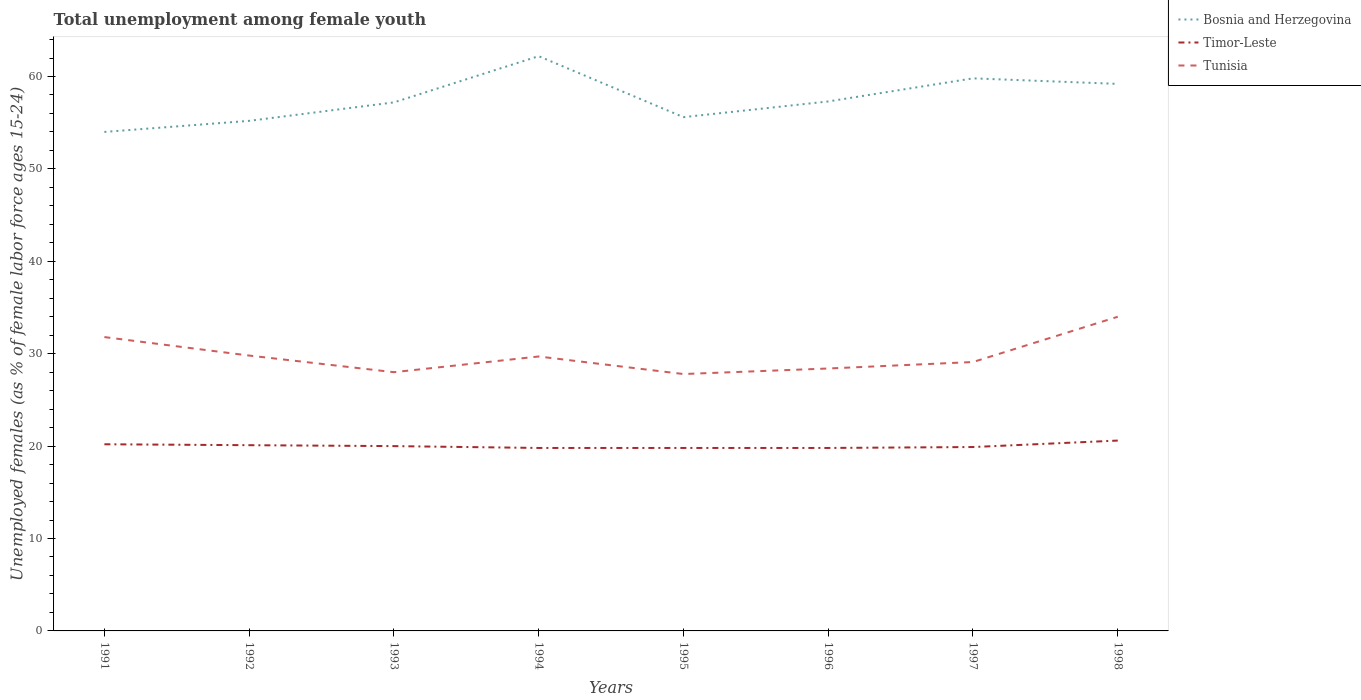Is the number of lines equal to the number of legend labels?
Give a very brief answer. Yes. Across all years, what is the maximum percentage of unemployed females in in Timor-Leste?
Make the answer very short. 19.8. What is the difference between the highest and the second highest percentage of unemployed females in in Timor-Leste?
Offer a very short reply. 0.8. What is the difference between the highest and the lowest percentage of unemployed females in in Bosnia and Herzegovina?
Make the answer very short. 3. Is the percentage of unemployed females in in Tunisia strictly greater than the percentage of unemployed females in in Bosnia and Herzegovina over the years?
Make the answer very short. Yes. How many years are there in the graph?
Provide a short and direct response. 8. What is the difference between two consecutive major ticks on the Y-axis?
Your answer should be very brief. 10. Are the values on the major ticks of Y-axis written in scientific E-notation?
Provide a succinct answer. No. Does the graph contain any zero values?
Offer a very short reply. No. Does the graph contain grids?
Ensure brevity in your answer.  No. Where does the legend appear in the graph?
Make the answer very short. Top right. How many legend labels are there?
Offer a very short reply. 3. How are the legend labels stacked?
Offer a very short reply. Vertical. What is the title of the graph?
Provide a short and direct response. Total unemployment among female youth. What is the label or title of the Y-axis?
Offer a terse response. Unemployed females (as % of female labor force ages 15-24). What is the Unemployed females (as % of female labor force ages 15-24) of Bosnia and Herzegovina in 1991?
Provide a short and direct response. 54. What is the Unemployed females (as % of female labor force ages 15-24) in Timor-Leste in 1991?
Provide a succinct answer. 20.2. What is the Unemployed females (as % of female labor force ages 15-24) of Tunisia in 1991?
Your answer should be very brief. 31.8. What is the Unemployed females (as % of female labor force ages 15-24) of Bosnia and Herzegovina in 1992?
Your answer should be compact. 55.2. What is the Unemployed females (as % of female labor force ages 15-24) of Timor-Leste in 1992?
Offer a terse response. 20.1. What is the Unemployed females (as % of female labor force ages 15-24) of Tunisia in 1992?
Make the answer very short. 29.8. What is the Unemployed females (as % of female labor force ages 15-24) in Bosnia and Herzegovina in 1993?
Offer a terse response. 57.2. What is the Unemployed females (as % of female labor force ages 15-24) in Tunisia in 1993?
Ensure brevity in your answer.  28. What is the Unemployed females (as % of female labor force ages 15-24) in Bosnia and Herzegovina in 1994?
Provide a short and direct response. 62.2. What is the Unemployed females (as % of female labor force ages 15-24) of Timor-Leste in 1994?
Keep it short and to the point. 19.8. What is the Unemployed females (as % of female labor force ages 15-24) of Tunisia in 1994?
Give a very brief answer. 29.7. What is the Unemployed females (as % of female labor force ages 15-24) of Bosnia and Herzegovina in 1995?
Your answer should be compact. 55.6. What is the Unemployed females (as % of female labor force ages 15-24) of Timor-Leste in 1995?
Provide a short and direct response. 19.8. What is the Unemployed females (as % of female labor force ages 15-24) of Tunisia in 1995?
Give a very brief answer. 27.8. What is the Unemployed females (as % of female labor force ages 15-24) of Bosnia and Herzegovina in 1996?
Make the answer very short. 57.3. What is the Unemployed females (as % of female labor force ages 15-24) of Timor-Leste in 1996?
Offer a terse response. 19.8. What is the Unemployed females (as % of female labor force ages 15-24) of Tunisia in 1996?
Your response must be concise. 28.4. What is the Unemployed females (as % of female labor force ages 15-24) of Bosnia and Herzegovina in 1997?
Ensure brevity in your answer.  59.8. What is the Unemployed females (as % of female labor force ages 15-24) of Timor-Leste in 1997?
Your answer should be very brief. 19.9. What is the Unemployed females (as % of female labor force ages 15-24) in Tunisia in 1997?
Offer a very short reply. 29.1. What is the Unemployed females (as % of female labor force ages 15-24) in Bosnia and Herzegovina in 1998?
Your response must be concise. 59.2. What is the Unemployed females (as % of female labor force ages 15-24) of Timor-Leste in 1998?
Offer a terse response. 20.6. What is the Unemployed females (as % of female labor force ages 15-24) of Tunisia in 1998?
Give a very brief answer. 34. Across all years, what is the maximum Unemployed females (as % of female labor force ages 15-24) of Bosnia and Herzegovina?
Provide a short and direct response. 62.2. Across all years, what is the maximum Unemployed females (as % of female labor force ages 15-24) in Timor-Leste?
Make the answer very short. 20.6. Across all years, what is the minimum Unemployed females (as % of female labor force ages 15-24) of Bosnia and Herzegovina?
Make the answer very short. 54. Across all years, what is the minimum Unemployed females (as % of female labor force ages 15-24) of Timor-Leste?
Ensure brevity in your answer.  19.8. Across all years, what is the minimum Unemployed females (as % of female labor force ages 15-24) in Tunisia?
Ensure brevity in your answer.  27.8. What is the total Unemployed females (as % of female labor force ages 15-24) in Bosnia and Herzegovina in the graph?
Ensure brevity in your answer.  460.5. What is the total Unemployed females (as % of female labor force ages 15-24) in Timor-Leste in the graph?
Provide a short and direct response. 160.2. What is the total Unemployed females (as % of female labor force ages 15-24) of Tunisia in the graph?
Your answer should be very brief. 238.6. What is the difference between the Unemployed females (as % of female labor force ages 15-24) of Bosnia and Herzegovina in 1991 and that in 1992?
Your response must be concise. -1.2. What is the difference between the Unemployed females (as % of female labor force ages 15-24) of Timor-Leste in 1991 and that in 1992?
Keep it short and to the point. 0.1. What is the difference between the Unemployed females (as % of female labor force ages 15-24) of Bosnia and Herzegovina in 1991 and that in 1993?
Ensure brevity in your answer.  -3.2. What is the difference between the Unemployed females (as % of female labor force ages 15-24) of Bosnia and Herzegovina in 1991 and that in 1995?
Provide a short and direct response. -1.6. What is the difference between the Unemployed females (as % of female labor force ages 15-24) of Tunisia in 1991 and that in 1995?
Offer a terse response. 4. What is the difference between the Unemployed females (as % of female labor force ages 15-24) of Tunisia in 1991 and that in 1996?
Ensure brevity in your answer.  3.4. What is the difference between the Unemployed females (as % of female labor force ages 15-24) of Timor-Leste in 1991 and that in 1997?
Ensure brevity in your answer.  0.3. What is the difference between the Unemployed females (as % of female labor force ages 15-24) of Tunisia in 1992 and that in 1993?
Keep it short and to the point. 1.8. What is the difference between the Unemployed females (as % of female labor force ages 15-24) of Bosnia and Herzegovina in 1992 and that in 1994?
Ensure brevity in your answer.  -7. What is the difference between the Unemployed females (as % of female labor force ages 15-24) of Tunisia in 1992 and that in 1994?
Make the answer very short. 0.1. What is the difference between the Unemployed females (as % of female labor force ages 15-24) of Timor-Leste in 1992 and that in 1995?
Offer a very short reply. 0.3. What is the difference between the Unemployed females (as % of female labor force ages 15-24) of Tunisia in 1992 and that in 1996?
Your answer should be compact. 1.4. What is the difference between the Unemployed females (as % of female labor force ages 15-24) in Timor-Leste in 1992 and that in 1997?
Give a very brief answer. 0.2. What is the difference between the Unemployed females (as % of female labor force ages 15-24) in Tunisia in 1992 and that in 1997?
Your response must be concise. 0.7. What is the difference between the Unemployed females (as % of female labor force ages 15-24) of Bosnia and Herzegovina in 1992 and that in 1998?
Give a very brief answer. -4. What is the difference between the Unemployed females (as % of female labor force ages 15-24) of Timor-Leste in 1992 and that in 1998?
Provide a short and direct response. -0.5. What is the difference between the Unemployed females (as % of female labor force ages 15-24) in Tunisia in 1992 and that in 1998?
Your response must be concise. -4.2. What is the difference between the Unemployed females (as % of female labor force ages 15-24) in Bosnia and Herzegovina in 1993 and that in 1994?
Ensure brevity in your answer.  -5. What is the difference between the Unemployed females (as % of female labor force ages 15-24) of Tunisia in 1993 and that in 1994?
Your answer should be very brief. -1.7. What is the difference between the Unemployed females (as % of female labor force ages 15-24) in Timor-Leste in 1993 and that in 1995?
Provide a short and direct response. 0.2. What is the difference between the Unemployed females (as % of female labor force ages 15-24) of Tunisia in 1993 and that in 1995?
Your answer should be compact. 0.2. What is the difference between the Unemployed females (as % of female labor force ages 15-24) of Bosnia and Herzegovina in 1993 and that in 1996?
Ensure brevity in your answer.  -0.1. What is the difference between the Unemployed females (as % of female labor force ages 15-24) of Timor-Leste in 1993 and that in 1997?
Your answer should be compact. 0.1. What is the difference between the Unemployed females (as % of female labor force ages 15-24) in Tunisia in 1993 and that in 1998?
Provide a short and direct response. -6. What is the difference between the Unemployed females (as % of female labor force ages 15-24) in Bosnia and Herzegovina in 1994 and that in 1995?
Offer a very short reply. 6.6. What is the difference between the Unemployed females (as % of female labor force ages 15-24) in Timor-Leste in 1994 and that in 1996?
Provide a short and direct response. 0. What is the difference between the Unemployed females (as % of female labor force ages 15-24) of Bosnia and Herzegovina in 1994 and that in 1997?
Offer a terse response. 2.4. What is the difference between the Unemployed females (as % of female labor force ages 15-24) in Tunisia in 1994 and that in 1997?
Offer a very short reply. 0.6. What is the difference between the Unemployed females (as % of female labor force ages 15-24) in Bosnia and Herzegovina in 1994 and that in 1998?
Offer a terse response. 3. What is the difference between the Unemployed females (as % of female labor force ages 15-24) in Timor-Leste in 1994 and that in 1998?
Provide a succinct answer. -0.8. What is the difference between the Unemployed females (as % of female labor force ages 15-24) of Bosnia and Herzegovina in 1995 and that in 1996?
Offer a terse response. -1.7. What is the difference between the Unemployed females (as % of female labor force ages 15-24) in Timor-Leste in 1995 and that in 1996?
Make the answer very short. 0. What is the difference between the Unemployed females (as % of female labor force ages 15-24) in Bosnia and Herzegovina in 1995 and that in 1997?
Offer a terse response. -4.2. What is the difference between the Unemployed females (as % of female labor force ages 15-24) in Timor-Leste in 1995 and that in 1997?
Make the answer very short. -0.1. What is the difference between the Unemployed females (as % of female labor force ages 15-24) of Tunisia in 1995 and that in 1997?
Give a very brief answer. -1.3. What is the difference between the Unemployed females (as % of female labor force ages 15-24) of Bosnia and Herzegovina in 1995 and that in 1998?
Your answer should be compact. -3.6. What is the difference between the Unemployed females (as % of female labor force ages 15-24) in Timor-Leste in 1995 and that in 1998?
Give a very brief answer. -0.8. What is the difference between the Unemployed females (as % of female labor force ages 15-24) of Tunisia in 1995 and that in 1998?
Make the answer very short. -6.2. What is the difference between the Unemployed females (as % of female labor force ages 15-24) of Tunisia in 1996 and that in 1997?
Offer a terse response. -0.7. What is the difference between the Unemployed females (as % of female labor force ages 15-24) of Timor-Leste in 1996 and that in 1998?
Give a very brief answer. -0.8. What is the difference between the Unemployed females (as % of female labor force ages 15-24) in Tunisia in 1996 and that in 1998?
Offer a very short reply. -5.6. What is the difference between the Unemployed females (as % of female labor force ages 15-24) in Timor-Leste in 1997 and that in 1998?
Offer a very short reply. -0.7. What is the difference between the Unemployed females (as % of female labor force ages 15-24) of Bosnia and Herzegovina in 1991 and the Unemployed females (as % of female labor force ages 15-24) of Timor-Leste in 1992?
Offer a very short reply. 33.9. What is the difference between the Unemployed females (as % of female labor force ages 15-24) in Bosnia and Herzegovina in 1991 and the Unemployed females (as % of female labor force ages 15-24) in Tunisia in 1992?
Your response must be concise. 24.2. What is the difference between the Unemployed females (as % of female labor force ages 15-24) of Bosnia and Herzegovina in 1991 and the Unemployed females (as % of female labor force ages 15-24) of Tunisia in 1993?
Ensure brevity in your answer.  26. What is the difference between the Unemployed females (as % of female labor force ages 15-24) of Timor-Leste in 1991 and the Unemployed females (as % of female labor force ages 15-24) of Tunisia in 1993?
Make the answer very short. -7.8. What is the difference between the Unemployed females (as % of female labor force ages 15-24) of Bosnia and Herzegovina in 1991 and the Unemployed females (as % of female labor force ages 15-24) of Timor-Leste in 1994?
Ensure brevity in your answer.  34.2. What is the difference between the Unemployed females (as % of female labor force ages 15-24) of Bosnia and Herzegovina in 1991 and the Unemployed females (as % of female labor force ages 15-24) of Tunisia in 1994?
Keep it short and to the point. 24.3. What is the difference between the Unemployed females (as % of female labor force ages 15-24) of Bosnia and Herzegovina in 1991 and the Unemployed females (as % of female labor force ages 15-24) of Timor-Leste in 1995?
Make the answer very short. 34.2. What is the difference between the Unemployed females (as % of female labor force ages 15-24) of Bosnia and Herzegovina in 1991 and the Unemployed females (as % of female labor force ages 15-24) of Tunisia in 1995?
Make the answer very short. 26.2. What is the difference between the Unemployed females (as % of female labor force ages 15-24) of Bosnia and Herzegovina in 1991 and the Unemployed females (as % of female labor force ages 15-24) of Timor-Leste in 1996?
Provide a short and direct response. 34.2. What is the difference between the Unemployed females (as % of female labor force ages 15-24) of Bosnia and Herzegovina in 1991 and the Unemployed females (as % of female labor force ages 15-24) of Tunisia in 1996?
Provide a succinct answer. 25.6. What is the difference between the Unemployed females (as % of female labor force ages 15-24) of Timor-Leste in 1991 and the Unemployed females (as % of female labor force ages 15-24) of Tunisia in 1996?
Your answer should be compact. -8.2. What is the difference between the Unemployed females (as % of female labor force ages 15-24) of Bosnia and Herzegovina in 1991 and the Unemployed females (as % of female labor force ages 15-24) of Timor-Leste in 1997?
Provide a succinct answer. 34.1. What is the difference between the Unemployed females (as % of female labor force ages 15-24) in Bosnia and Herzegovina in 1991 and the Unemployed females (as % of female labor force ages 15-24) in Tunisia in 1997?
Offer a very short reply. 24.9. What is the difference between the Unemployed females (as % of female labor force ages 15-24) of Bosnia and Herzegovina in 1991 and the Unemployed females (as % of female labor force ages 15-24) of Timor-Leste in 1998?
Offer a terse response. 33.4. What is the difference between the Unemployed females (as % of female labor force ages 15-24) of Bosnia and Herzegovina in 1991 and the Unemployed females (as % of female labor force ages 15-24) of Tunisia in 1998?
Keep it short and to the point. 20. What is the difference between the Unemployed females (as % of female labor force ages 15-24) in Timor-Leste in 1991 and the Unemployed females (as % of female labor force ages 15-24) in Tunisia in 1998?
Ensure brevity in your answer.  -13.8. What is the difference between the Unemployed females (as % of female labor force ages 15-24) in Bosnia and Herzegovina in 1992 and the Unemployed females (as % of female labor force ages 15-24) in Timor-Leste in 1993?
Ensure brevity in your answer.  35.2. What is the difference between the Unemployed females (as % of female labor force ages 15-24) of Bosnia and Herzegovina in 1992 and the Unemployed females (as % of female labor force ages 15-24) of Tunisia in 1993?
Provide a short and direct response. 27.2. What is the difference between the Unemployed females (as % of female labor force ages 15-24) in Timor-Leste in 1992 and the Unemployed females (as % of female labor force ages 15-24) in Tunisia in 1993?
Offer a terse response. -7.9. What is the difference between the Unemployed females (as % of female labor force ages 15-24) of Bosnia and Herzegovina in 1992 and the Unemployed females (as % of female labor force ages 15-24) of Timor-Leste in 1994?
Give a very brief answer. 35.4. What is the difference between the Unemployed females (as % of female labor force ages 15-24) of Bosnia and Herzegovina in 1992 and the Unemployed females (as % of female labor force ages 15-24) of Tunisia in 1994?
Keep it short and to the point. 25.5. What is the difference between the Unemployed females (as % of female labor force ages 15-24) of Timor-Leste in 1992 and the Unemployed females (as % of female labor force ages 15-24) of Tunisia in 1994?
Your answer should be very brief. -9.6. What is the difference between the Unemployed females (as % of female labor force ages 15-24) in Bosnia and Herzegovina in 1992 and the Unemployed females (as % of female labor force ages 15-24) in Timor-Leste in 1995?
Give a very brief answer. 35.4. What is the difference between the Unemployed females (as % of female labor force ages 15-24) in Bosnia and Herzegovina in 1992 and the Unemployed females (as % of female labor force ages 15-24) in Tunisia in 1995?
Offer a terse response. 27.4. What is the difference between the Unemployed females (as % of female labor force ages 15-24) of Timor-Leste in 1992 and the Unemployed females (as % of female labor force ages 15-24) of Tunisia in 1995?
Provide a succinct answer. -7.7. What is the difference between the Unemployed females (as % of female labor force ages 15-24) of Bosnia and Herzegovina in 1992 and the Unemployed females (as % of female labor force ages 15-24) of Timor-Leste in 1996?
Your answer should be very brief. 35.4. What is the difference between the Unemployed females (as % of female labor force ages 15-24) in Bosnia and Herzegovina in 1992 and the Unemployed females (as % of female labor force ages 15-24) in Tunisia in 1996?
Give a very brief answer. 26.8. What is the difference between the Unemployed females (as % of female labor force ages 15-24) of Timor-Leste in 1992 and the Unemployed females (as % of female labor force ages 15-24) of Tunisia in 1996?
Ensure brevity in your answer.  -8.3. What is the difference between the Unemployed females (as % of female labor force ages 15-24) in Bosnia and Herzegovina in 1992 and the Unemployed females (as % of female labor force ages 15-24) in Timor-Leste in 1997?
Your answer should be compact. 35.3. What is the difference between the Unemployed females (as % of female labor force ages 15-24) of Bosnia and Herzegovina in 1992 and the Unemployed females (as % of female labor force ages 15-24) of Tunisia in 1997?
Your answer should be compact. 26.1. What is the difference between the Unemployed females (as % of female labor force ages 15-24) in Timor-Leste in 1992 and the Unemployed females (as % of female labor force ages 15-24) in Tunisia in 1997?
Keep it short and to the point. -9. What is the difference between the Unemployed females (as % of female labor force ages 15-24) of Bosnia and Herzegovina in 1992 and the Unemployed females (as % of female labor force ages 15-24) of Timor-Leste in 1998?
Your response must be concise. 34.6. What is the difference between the Unemployed females (as % of female labor force ages 15-24) in Bosnia and Herzegovina in 1992 and the Unemployed females (as % of female labor force ages 15-24) in Tunisia in 1998?
Offer a terse response. 21.2. What is the difference between the Unemployed females (as % of female labor force ages 15-24) in Bosnia and Herzegovina in 1993 and the Unemployed females (as % of female labor force ages 15-24) in Timor-Leste in 1994?
Offer a very short reply. 37.4. What is the difference between the Unemployed females (as % of female labor force ages 15-24) of Bosnia and Herzegovina in 1993 and the Unemployed females (as % of female labor force ages 15-24) of Timor-Leste in 1995?
Your answer should be compact. 37.4. What is the difference between the Unemployed females (as % of female labor force ages 15-24) of Bosnia and Herzegovina in 1993 and the Unemployed females (as % of female labor force ages 15-24) of Tunisia in 1995?
Provide a succinct answer. 29.4. What is the difference between the Unemployed females (as % of female labor force ages 15-24) in Timor-Leste in 1993 and the Unemployed females (as % of female labor force ages 15-24) in Tunisia in 1995?
Offer a terse response. -7.8. What is the difference between the Unemployed females (as % of female labor force ages 15-24) of Bosnia and Herzegovina in 1993 and the Unemployed females (as % of female labor force ages 15-24) of Timor-Leste in 1996?
Offer a terse response. 37.4. What is the difference between the Unemployed females (as % of female labor force ages 15-24) in Bosnia and Herzegovina in 1993 and the Unemployed females (as % of female labor force ages 15-24) in Tunisia in 1996?
Keep it short and to the point. 28.8. What is the difference between the Unemployed females (as % of female labor force ages 15-24) in Bosnia and Herzegovina in 1993 and the Unemployed females (as % of female labor force ages 15-24) in Timor-Leste in 1997?
Keep it short and to the point. 37.3. What is the difference between the Unemployed females (as % of female labor force ages 15-24) of Bosnia and Herzegovina in 1993 and the Unemployed females (as % of female labor force ages 15-24) of Tunisia in 1997?
Your response must be concise. 28.1. What is the difference between the Unemployed females (as % of female labor force ages 15-24) of Bosnia and Herzegovina in 1993 and the Unemployed females (as % of female labor force ages 15-24) of Timor-Leste in 1998?
Your answer should be compact. 36.6. What is the difference between the Unemployed females (as % of female labor force ages 15-24) of Bosnia and Herzegovina in 1993 and the Unemployed females (as % of female labor force ages 15-24) of Tunisia in 1998?
Give a very brief answer. 23.2. What is the difference between the Unemployed females (as % of female labor force ages 15-24) in Bosnia and Herzegovina in 1994 and the Unemployed females (as % of female labor force ages 15-24) in Timor-Leste in 1995?
Give a very brief answer. 42.4. What is the difference between the Unemployed females (as % of female labor force ages 15-24) in Bosnia and Herzegovina in 1994 and the Unemployed females (as % of female labor force ages 15-24) in Tunisia in 1995?
Make the answer very short. 34.4. What is the difference between the Unemployed females (as % of female labor force ages 15-24) of Timor-Leste in 1994 and the Unemployed females (as % of female labor force ages 15-24) of Tunisia in 1995?
Ensure brevity in your answer.  -8. What is the difference between the Unemployed females (as % of female labor force ages 15-24) of Bosnia and Herzegovina in 1994 and the Unemployed females (as % of female labor force ages 15-24) of Timor-Leste in 1996?
Provide a succinct answer. 42.4. What is the difference between the Unemployed females (as % of female labor force ages 15-24) of Bosnia and Herzegovina in 1994 and the Unemployed females (as % of female labor force ages 15-24) of Tunisia in 1996?
Your answer should be compact. 33.8. What is the difference between the Unemployed females (as % of female labor force ages 15-24) of Bosnia and Herzegovina in 1994 and the Unemployed females (as % of female labor force ages 15-24) of Timor-Leste in 1997?
Offer a very short reply. 42.3. What is the difference between the Unemployed females (as % of female labor force ages 15-24) of Bosnia and Herzegovina in 1994 and the Unemployed females (as % of female labor force ages 15-24) of Tunisia in 1997?
Provide a succinct answer. 33.1. What is the difference between the Unemployed females (as % of female labor force ages 15-24) of Timor-Leste in 1994 and the Unemployed females (as % of female labor force ages 15-24) of Tunisia in 1997?
Provide a short and direct response. -9.3. What is the difference between the Unemployed females (as % of female labor force ages 15-24) in Bosnia and Herzegovina in 1994 and the Unemployed females (as % of female labor force ages 15-24) in Timor-Leste in 1998?
Keep it short and to the point. 41.6. What is the difference between the Unemployed females (as % of female labor force ages 15-24) of Bosnia and Herzegovina in 1994 and the Unemployed females (as % of female labor force ages 15-24) of Tunisia in 1998?
Your answer should be compact. 28.2. What is the difference between the Unemployed females (as % of female labor force ages 15-24) of Bosnia and Herzegovina in 1995 and the Unemployed females (as % of female labor force ages 15-24) of Timor-Leste in 1996?
Offer a very short reply. 35.8. What is the difference between the Unemployed females (as % of female labor force ages 15-24) in Bosnia and Herzegovina in 1995 and the Unemployed females (as % of female labor force ages 15-24) in Tunisia in 1996?
Provide a short and direct response. 27.2. What is the difference between the Unemployed females (as % of female labor force ages 15-24) in Timor-Leste in 1995 and the Unemployed females (as % of female labor force ages 15-24) in Tunisia in 1996?
Ensure brevity in your answer.  -8.6. What is the difference between the Unemployed females (as % of female labor force ages 15-24) in Bosnia and Herzegovina in 1995 and the Unemployed females (as % of female labor force ages 15-24) in Timor-Leste in 1997?
Your response must be concise. 35.7. What is the difference between the Unemployed females (as % of female labor force ages 15-24) of Bosnia and Herzegovina in 1995 and the Unemployed females (as % of female labor force ages 15-24) of Tunisia in 1997?
Provide a short and direct response. 26.5. What is the difference between the Unemployed females (as % of female labor force ages 15-24) of Timor-Leste in 1995 and the Unemployed females (as % of female labor force ages 15-24) of Tunisia in 1997?
Provide a short and direct response. -9.3. What is the difference between the Unemployed females (as % of female labor force ages 15-24) of Bosnia and Herzegovina in 1995 and the Unemployed females (as % of female labor force ages 15-24) of Timor-Leste in 1998?
Offer a terse response. 35. What is the difference between the Unemployed females (as % of female labor force ages 15-24) in Bosnia and Herzegovina in 1995 and the Unemployed females (as % of female labor force ages 15-24) in Tunisia in 1998?
Offer a very short reply. 21.6. What is the difference between the Unemployed females (as % of female labor force ages 15-24) in Timor-Leste in 1995 and the Unemployed females (as % of female labor force ages 15-24) in Tunisia in 1998?
Provide a succinct answer. -14.2. What is the difference between the Unemployed females (as % of female labor force ages 15-24) in Bosnia and Herzegovina in 1996 and the Unemployed females (as % of female labor force ages 15-24) in Timor-Leste in 1997?
Your response must be concise. 37.4. What is the difference between the Unemployed females (as % of female labor force ages 15-24) in Bosnia and Herzegovina in 1996 and the Unemployed females (as % of female labor force ages 15-24) in Tunisia in 1997?
Your answer should be very brief. 28.2. What is the difference between the Unemployed females (as % of female labor force ages 15-24) of Bosnia and Herzegovina in 1996 and the Unemployed females (as % of female labor force ages 15-24) of Timor-Leste in 1998?
Offer a very short reply. 36.7. What is the difference between the Unemployed females (as % of female labor force ages 15-24) in Bosnia and Herzegovina in 1996 and the Unemployed females (as % of female labor force ages 15-24) in Tunisia in 1998?
Keep it short and to the point. 23.3. What is the difference between the Unemployed females (as % of female labor force ages 15-24) of Timor-Leste in 1996 and the Unemployed females (as % of female labor force ages 15-24) of Tunisia in 1998?
Your answer should be compact. -14.2. What is the difference between the Unemployed females (as % of female labor force ages 15-24) in Bosnia and Herzegovina in 1997 and the Unemployed females (as % of female labor force ages 15-24) in Timor-Leste in 1998?
Make the answer very short. 39.2. What is the difference between the Unemployed females (as % of female labor force ages 15-24) of Bosnia and Herzegovina in 1997 and the Unemployed females (as % of female labor force ages 15-24) of Tunisia in 1998?
Provide a short and direct response. 25.8. What is the difference between the Unemployed females (as % of female labor force ages 15-24) in Timor-Leste in 1997 and the Unemployed females (as % of female labor force ages 15-24) in Tunisia in 1998?
Give a very brief answer. -14.1. What is the average Unemployed females (as % of female labor force ages 15-24) in Bosnia and Herzegovina per year?
Provide a short and direct response. 57.56. What is the average Unemployed females (as % of female labor force ages 15-24) in Timor-Leste per year?
Give a very brief answer. 20.02. What is the average Unemployed females (as % of female labor force ages 15-24) of Tunisia per year?
Make the answer very short. 29.82. In the year 1991, what is the difference between the Unemployed females (as % of female labor force ages 15-24) of Bosnia and Herzegovina and Unemployed females (as % of female labor force ages 15-24) of Timor-Leste?
Keep it short and to the point. 33.8. In the year 1991, what is the difference between the Unemployed females (as % of female labor force ages 15-24) of Timor-Leste and Unemployed females (as % of female labor force ages 15-24) of Tunisia?
Offer a terse response. -11.6. In the year 1992, what is the difference between the Unemployed females (as % of female labor force ages 15-24) in Bosnia and Herzegovina and Unemployed females (as % of female labor force ages 15-24) in Timor-Leste?
Offer a very short reply. 35.1. In the year 1992, what is the difference between the Unemployed females (as % of female labor force ages 15-24) in Bosnia and Herzegovina and Unemployed females (as % of female labor force ages 15-24) in Tunisia?
Keep it short and to the point. 25.4. In the year 1992, what is the difference between the Unemployed females (as % of female labor force ages 15-24) of Timor-Leste and Unemployed females (as % of female labor force ages 15-24) of Tunisia?
Offer a terse response. -9.7. In the year 1993, what is the difference between the Unemployed females (as % of female labor force ages 15-24) of Bosnia and Herzegovina and Unemployed females (as % of female labor force ages 15-24) of Timor-Leste?
Your answer should be compact. 37.2. In the year 1993, what is the difference between the Unemployed females (as % of female labor force ages 15-24) in Bosnia and Herzegovina and Unemployed females (as % of female labor force ages 15-24) in Tunisia?
Make the answer very short. 29.2. In the year 1993, what is the difference between the Unemployed females (as % of female labor force ages 15-24) in Timor-Leste and Unemployed females (as % of female labor force ages 15-24) in Tunisia?
Offer a terse response. -8. In the year 1994, what is the difference between the Unemployed females (as % of female labor force ages 15-24) of Bosnia and Herzegovina and Unemployed females (as % of female labor force ages 15-24) of Timor-Leste?
Your response must be concise. 42.4. In the year 1994, what is the difference between the Unemployed females (as % of female labor force ages 15-24) of Bosnia and Herzegovina and Unemployed females (as % of female labor force ages 15-24) of Tunisia?
Make the answer very short. 32.5. In the year 1995, what is the difference between the Unemployed females (as % of female labor force ages 15-24) of Bosnia and Herzegovina and Unemployed females (as % of female labor force ages 15-24) of Timor-Leste?
Offer a very short reply. 35.8. In the year 1995, what is the difference between the Unemployed females (as % of female labor force ages 15-24) of Bosnia and Herzegovina and Unemployed females (as % of female labor force ages 15-24) of Tunisia?
Provide a succinct answer. 27.8. In the year 1996, what is the difference between the Unemployed females (as % of female labor force ages 15-24) of Bosnia and Herzegovina and Unemployed females (as % of female labor force ages 15-24) of Timor-Leste?
Provide a succinct answer. 37.5. In the year 1996, what is the difference between the Unemployed females (as % of female labor force ages 15-24) of Bosnia and Herzegovina and Unemployed females (as % of female labor force ages 15-24) of Tunisia?
Your answer should be compact. 28.9. In the year 1996, what is the difference between the Unemployed females (as % of female labor force ages 15-24) of Timor-Leste and Unemployed females (as % of female labor force ages 15-24) of Tunisia?
Offer a very short reply. -8.6. In the year 1997, what is the difference between the Unemployed females (as % of female labor force ages 15-24) in Bosnia and Herzegovina and Unemployed females (as % of female labor force ages 15-24) in Timor-Leste?
Your answer should be very brief. 39.9. In the year 1997, what is the difference between the Unemployed females (as % of female labor force ages 15-24) of Bosnia and Herzegovina and Unemployed females (as % of female labor force ages 15-24) of Tunisia?
Make the answer very short. 30.7. In the year 1997, what is the difference between the Unemployed females (as % of female labor force ages 15-24) of Timor-Leste and Unemployed females (as % of female labor force ages 15-24) of Tunisia?
Your answer should be compact. -9.2. In the year 1998, what is the difference between the Unemployed females (as % of female labor force ages 15-24) in Bosnia and Herzegovina and Unemployed females (as % of female labor force ages 15-24) in Timor-Leste?
Keep it short and to the point. 38.6. In the year 1998, what is the difference between the Unemployed females (as % of female labor force ages 15-24) in Bosnia and Herzegovina and Unemployed females (as % of female labor force ages 15-24) in Tunisia?
Your answer should be very brief. 25.2. In the year 1998, what is the difference between the Unemployed females (as % of female labor force ages 15-24) in Timor-Leste and Unemployed females (as % of female labor force ages 15-24) in Tunisia?
Provide a short and direct response. -13.4. What is the ratio of the Unemployed females (as % of female labor force ages 15-24) of Bosnia and Herzegovina in 1991 to that in 1992?
Make the answer very short. 0.98. What is the ratio of the Unemployed females (as % of female labor force ages 15-24) in Tunisia in 1991 to that in 1992?
Your answer should be compact. 1.07. What is the ratio of the Unemployed females (as % of female labor force ages 15-24) of Bosnia and Herzegovina in 1991 to that in 1993?
Offer a terse response. 0.94. What is the ratio of the Unemployed females (as % of female labor force ages 15-24) of Timor-Leste in 1991 to that in 1993?
Offer a very short reply. 1.01. What is the ratio of the Unemployed females (as % of female labor force ages 15-24) in Tunisia in 1991 to that in 1993?
Make the answer very short. 1.14. What is the ratio of the Unemployed females (as % of female labor force ages 15-24) in Bosnia and Herzegovina in 1991 to that in 1994?
Provide a succinct answer. 0.87. What is the ratio of the Unemployed females (as % of female labor force ages 15-24) of Timor-Leste in 1991 to that in 1994?
Ensure brevity in your answer.  1.02. What is the ratio of the Unemployed females (as % of female labor force ages 15-24) in Tunisia in 1991 to that in 1994?
Make the answer very short. 1.07. What is the ratio of the Unemployed females (as % of female labor force ages 15-24) in Bosnia and Herzegovina in 1991 to that in 1995?
Give a very brief answer. 0.97. What is the ratio of the Unemployed females (as % of female labor force ages 15-24) of Timor-Leste in 1991 to that in 1995?
Provide a succinct answer. 1.02. What is the ratio of the Unemployed females (as % of female labor force ages 15-24) of Tunisia in 1991 to that in 1995?
Provide a short and direct response. 1.14. What is the ratio of the Unemployed females (as % of female labor force ages 15-24) in Bosnia and Herzegovina in 1991 to that in 1996?
Ensure brevity in your answer.  0.94. What is the ratio of the Unemployed females (as % of female labor force ages 15-24) of Timor-Leste in 1991 to that in 1996?
Give a very brief answer. 1.02. What is the ratio of the Unemployed females (as % of female labor force ages 15-24) in Tunisia in 1991 to that in 1996?
Provide a short and direct response. 1.12. What is the ratio of the Unemployed females (as % of female labor force ages 15-24) in Bosnia and Herzegovina in 1991 to that in 1997?
Your response must be concise. 0.9. What is the ratio of the Unemployed females (as % of female labor force ages 15-24) in Timor-Leste in 1991 to that in 1997?
Give a very brief answer. 1.02. What is the ratio of the Unemployed females (as % of female labor force ages 15-24) in Tunisia in 1991 to that in 1997?
Your answer should be very brief. 1.09. What is the ratio of the Unemployed females (as % of female labor force ages 15-24) of Bosnia and Herzegovina in 1991 to that in 1998?
Your answer should be very brief. 0.91. What is the ratio of the Unemployed females (as % of female labor force ages 15-24) of Timor-Leste in 1991 to that in 1998?
Make the answer very short. 0.98. What is the ratio of the Unemployed females (as % of female labor force ages 15-24) in Tunisia in 1991 to that in 1998?
Your response must be concise. 0.94. What is the ratio of the Unemployed females (as % of female labor force ages 15-24) in Bosnia and Herzegovina in 1992 to that in 1993?
Give a very brief answer. 0.96. What is the ratio of the Unemployed females (as % of female labor force ages 15-24) in Timor-Leste in 1992 to that in 1993?
Keep it short and to the point. 1. What is the ratio of the Unemployed females (as % of female labor force ages 15-24) in Tunisia in 1992 to that in 1993?
Offer a very short reply. 1.06. What is the ratio of the Unemployed females (as % of female labor force ages 15-24) in Bosnia and Herzegovina in 1992 to that in 1994?
Offer a terse response. 0.89. What is the ratio of the Unemployed females (as % of female labor force ages 15-24) in Timor-Leste in 1992 to that in 1994?
Your answer should be very brief. 1.02. What is the ratio of the Unemployed females (as % of female labor force ages 15-24) in Tunisia in 1992 to that in 1994?
Keep it short and to the point. 1. What is the ratio of the Unemployed females (as % of female labor force ages 15-24) in Timor-Leste in 1992 to that in 1995?
Keep it short and to the point. 1.02. What is the ratio of the Unemployed females (as % of female labor force ages 15-24) in Tunisia in 1992 to that in 1995?
Ensure brevity in your answer.  1.07. What is the ratio of the Unemployed females (as % of female labor force ages 15-24) in Bosnia and Herzegovina in 1992 to that in 1996?
Your response must be concise. 0.96. What is the ratio of the Unemployed females (as % of female labor force ages 15-24) in Timor-Leste in 1992 to that in 1996?
Your answer should be compact. 1.02. What is the ratio of the Unemployed females (as % of female labor force ages 15-24) of Tunisia in 1992 to that in 1996?
Provide a succinct answer. 1.05. What is the ratio of the Unemployed females (as % of female labor force ages 15-24) in Bosnia and Herzegovina in 1992 to that in 1997?
Give a very brief answer. 0.92. What is the ratio of the Unemployed females (as % of female labor force ages 15-24) of Tunisia in 1992 to that in 1997?
Ensure brevity in your answer.  1.02. What is the ratio of the Unemployed females (as % of female labor force ages 15-24) of Bosnia and Herzegovina in 1992 to that in 1998?
Your answer should be compact. 0.93. What is the ratio of the Unemployed females (as % of female labor force ages 15-24) in Timor-Leste in 1992 to that in 1998?
Offer a very short reply. 0.98. What is the ratio of the Unemployed females (as % of female labor force ages 15-24) in Tunisia in 1992 to that in 1998?
Provide a succinct answer. 0.88. What is the ratio of the Unemployed females (as % of female labor force ages 15-24) of Bosnia and Herzegovina in 1993 to that in 1994?
Offer a very short reply. 0.92. What is the ratio of the Unemployed females (as % of female labor force ages 15-24) of Tunisia in 1993 to that in 1994?
Provide a short and direct response. 0.94. What is the ratio of the Unemployed females (as % of female labor force ages 15-24) in Bosnia and Herzegovina in 1993 to that in 1995?
Offer a terse response. 1.03. What is the ratio of the Unemployed females (as % of female labor force ages 15-24) in Tunisia in 1993 to that in 1996?
Your answer should be compact. 0.99. What is the ratio of the Unemployed females (as % of female labor force ages 15-24) of Bosnia and Herzegovina in 1993 to that in 1997?
Provide a short and direct response. 0.96. What is the ratio of the Unemployed females (as % of female labor force ages 15-24) in Timor-Leste in 1993 to that in 1997?
Offer a terse response. 1. What is the ratio of the Unemployed females (as % of female labor force ages 15-24) of Tunisia in 1993 to that in 1997?
Make the answer very short. 0.96. What is the ratio of the Unemployed females (as % of female labor force ages 15-24) of Bosnia and Herzegovina in 1993 to that in 1998?
Provide a short and direct response. 0.97. What is the ratio of the Unemployed females (as % of female labor force ages 15-24) in Timor-Leste in 1993 to that in 1998?
Ensure brevity in your answer.  0.97. What is the ratio of the Unemployed females (as % of female labor force ages 15-24) of Tunisia in 1993 to that in 1998?
Give a very brief answer. 0.82. What is the ratio of the Unemployed females (as % of female labor force ages 15-24) of Bosnia and Herzegovina in 1994 to that in 1995?
Your response must be concise. 1.12. What is the ratio of the Unemployed females (as % of female labor force ages 15-24) of Timor-Leste in 1994 to that in 1995?
Give a very brief answer. 1. What is the ratio of the Unemployed females (as % of female labor force ages 15-24) in Tunisia in 1994 to that in 1995?
Offer a very short reply. 1.07. What is the ratio of the Unemployed females (as % of female labor force ages 15-24) of Bosnia and Herzegovina in 1994 to that in 1996?
Ensure brevity in your answer.  1.09. What is the ratio of the Unemployed females (as % of female labor force ages 15-24) in Tunisia in 1994 to that in 1996?
Ensure brevity in your answer.  1.05. What is the ratio of the Unemployed females (as % of female labor force ages 15-24) in Bosnia and Herzegovina in 1994 to that in 1997?
Make the answer very short. 1.04. What is the ratio of the Unemployed females (as % of female labor force ages 15-24) of Tunisia in 1994 to that in 1997?
Ensure brevity in your answer.  1.02. What is the ratio of the Unemployed females (as % of female labor force ages 15-24) of Bosnia and Herzegovina in 1994 to that in 1998?
Ensure brevity in your answer.  1.05. What is the ratio of the Unemployed females (as % of female labor force ages 15-24) of Timor-Leste in 1994 to that in 1998?
Provide a short and direct response. 0.96. What is the ratio of the Unemployed females (as % of female labor force ages 15-24) of Tunisia in 1994 to that in 1998?
Keep it short and to the point. 0.87. What is the ratio of the Unemployed females (as % of female labor force ages 15-24) in Bosnia and Herzegovina in 1995 to that in 1996?
Keep it short and to the point. 0.97. What is the ratio of the Unemployed females (as % of female labor force ages 15-24) of Tunisia in 1995 to that in 1996?
Offer a very short reply. 0.98. What is the ratio of the Unemployed females (as % of female labor force ages 15-24) of Bosnia and Herzegovina in 1995 to that in 1997?
Ensure brevity in your answer.  0.93. What is the ratio of the Unemployed females (as % of female labor force ages 15-24) of Tunisia in 1995 to that in 1997?
Provide a succinct answer. 0.96. What is the ratio of the Unemployed females (as % of female labor force ages 15-24) of Bosnia and Herzegovina in 1995 to that in 1998?
Keep it short and to the point. 0.94. What is the ratio of the Unemployed females (as % of female labor force ages 15-24) in Timor-Leste in 1995 to that in 1998?
Offer a terse response. 0.96. What is the ratio of the Unemployed females (as % of female labor force ages 15-24) in Tunisia in 1995 to that in 1998?
Your response must be concise. 0.82. What is the ratio of the Unemployed females (as % of female labor force ages 15-24) in Bosnia and Herzegovina in 1996 to that in 1997?
Provide a short and direct response. 0.96. What is the ratio of the Unemployed females (as % of female labor force ages 15-24) in Tunisia in 1996 to that in 1997?
Your answer should be compact. 0.98. What is the ratio of the Unemployed females (as % of female labor force ages 15-24) in Bosnia and Herzegovina in 1996 to that in 1998?
Ensure brevity in your answer.  0.97. What is the ratio of the Unemployed females (as % of female labor force ages 15-24) of Timor-Leste in 1996 to that in 1998?
Give a very brief answer. 0.96. What is the ratio of the Unemployed females (as % of female labor force ages 15-24) of Tunisia in 1996 to that in 1998?
Provide a succinct answer. 0.84. What is the ratio of the Unemployed females (as % of female labor force ages 15-24) in Timor-Leste in 1997 to that in 1998?
Give a very brief answer. 0.97. What is the ratio of the Unemployed females (as % of female labor force ages 15-24) in Tunisia in 1997 to that in 1998?
Your answer should be very brief. 0.86. What is the difference between the highest and the second highest Unemployed females (as % of female labor force ages 15-24) in Bosnia and Herzegovina?
Your response must be concise. 2.4. What is the difference between the highest and the second highest Unemployed females (as % of female labor force ages 15-24) in Tunisia?
Give a very brief answer. 2.2. What is the difference between the highest and the lowest Unemployed females (as % of female labor force ages 15-24) in Bosnia and Herzegovina?
Give a very brief answer. 8.2. What is the difference between the highest and the lowest Unemployed females (as % of female labor force ages 15-24) of Timor-Leste?
Ensure brevity in your answer.  0.8. 